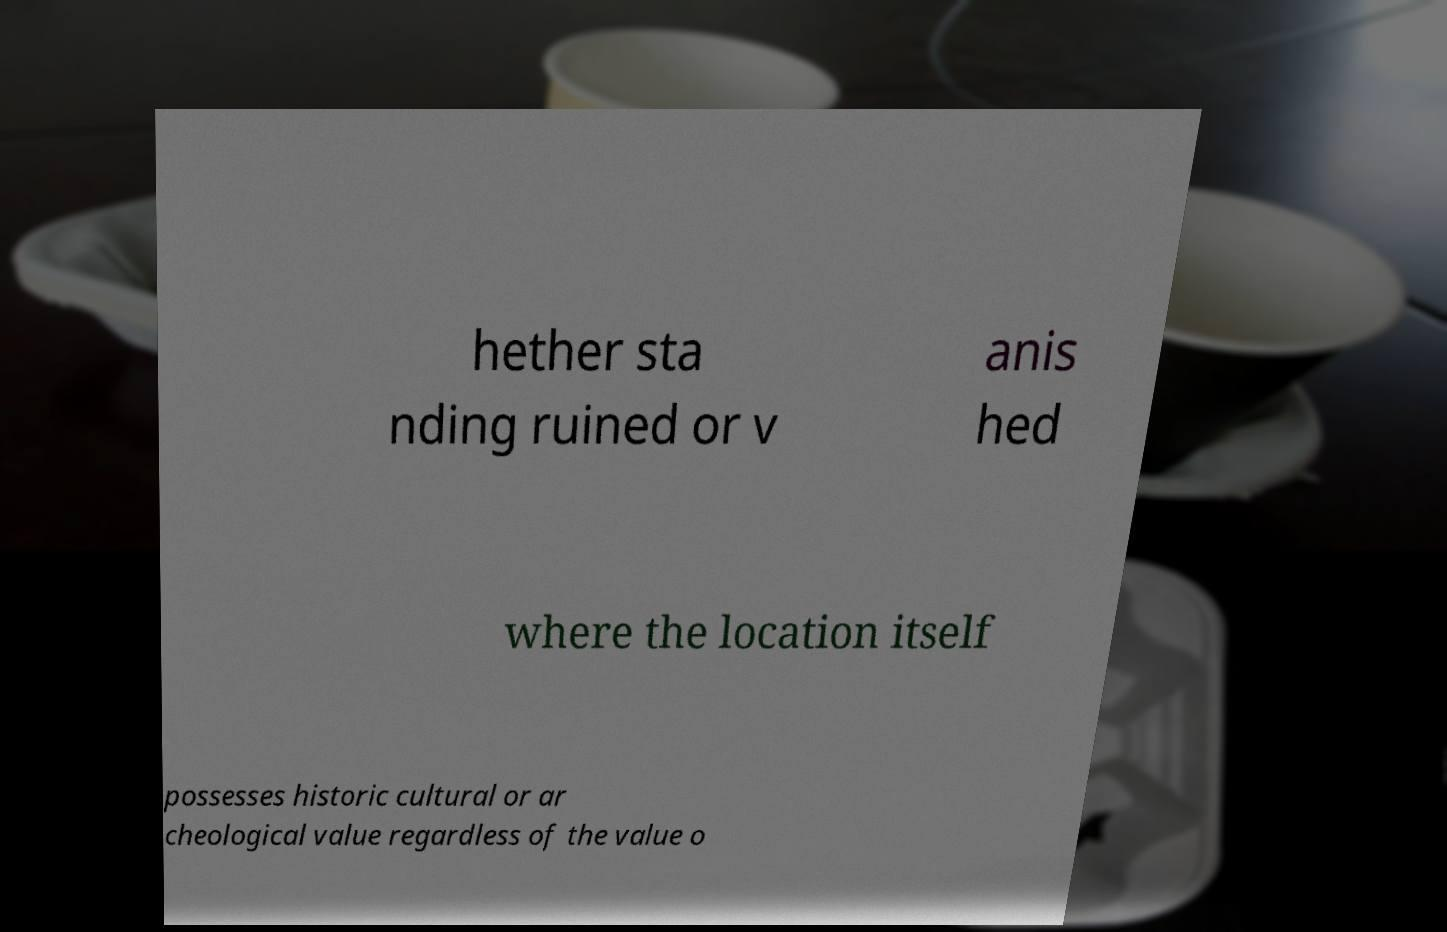I need the written content from this picture converted into text. Can you do that? hether sta nding ruined or v anis hed where the location itself possesses historic cultural or ar cheological value regardless of the value o 